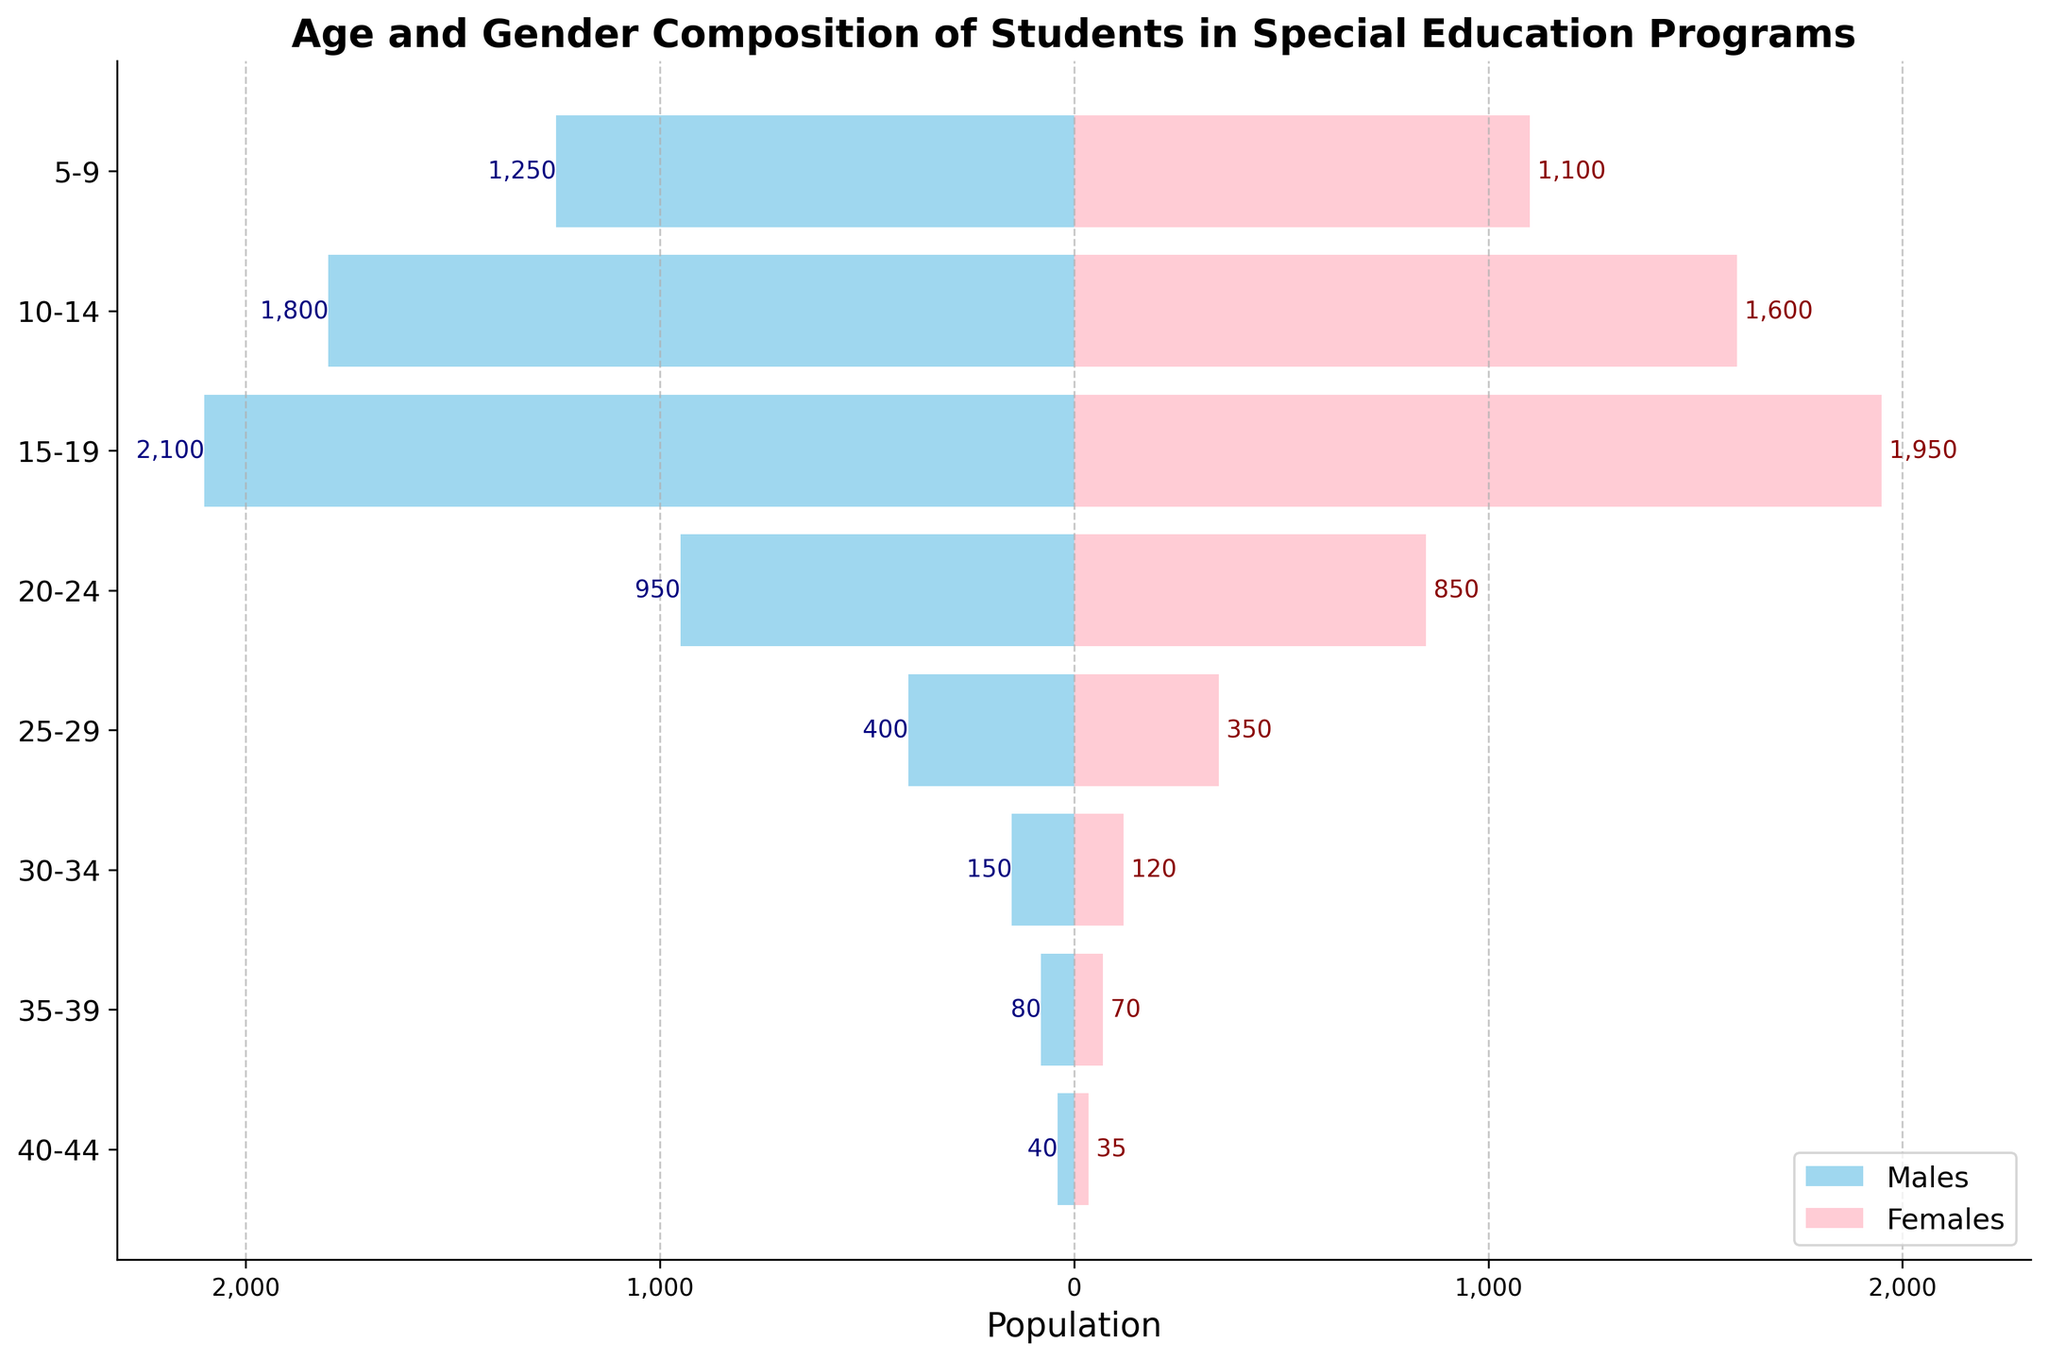What is the title of the figure? The title of the figure is displayed at the top.
Answer: Age and Gender Composition of Students in Special Education Programs What age group has the highest number of males enrolled in special education programs? By looking at the horizontal bars on the left side, the largest bar represents the age group with the highest number of males.
Answer: 15-19 How many females are in the 25-29 age group? By referring to the length of the pink bar for the 25-29 age group, you can determine the number of females.
Answer: 350 What is the difference between the number of males and females in the 10-14 age group? Subtract the number of females (1600) from the number of males (1800) in the 10-14 age group.
Answer: 200 Which age group has the smallest population in special education programs? Locate the shortest bars on both sides of the chart, indicating the smallest populations for both males and females combined.
Answer: 40-44 What is the total population of students in special education programs in the 15-19 age group? Add the number of males (2100) and females (1950) in the 15-19 age group.
Answer: 4050 Compare the number of students in special education programs in the 5-9 age group and the 35-39 age group. Which group is larger? Sum the number of males and females for both age groups and compare. For 5-9: 1250 males + 1100 females = 2350. For 35-39: 80 males + 70 females = 150.
Answer: 5-9 What percentage of students in the 20-24 age group are males? Divide the number of males (950) by the total number of students in the 20-24 age group (950 males + 850 females), then multiply by 100.
Answer: 52.78% How does the number of males change from the 10-14 age group to the 15-19 age group? Subtract the number of males in the 10-14 group (1800) from the number of males in the 15-19 group (2100).
Answer: Increase by 300 Compare the total number of students in the 25-29 and 30-34 age groups. Which is larger, and by how much? Calculate the total for 25-29: 400 males + 350 females = 750. For 30-34: 150 males + 120 females = 270. Subtract the smaller total from the larger total.
Answer: 25-29 is larger by 480 